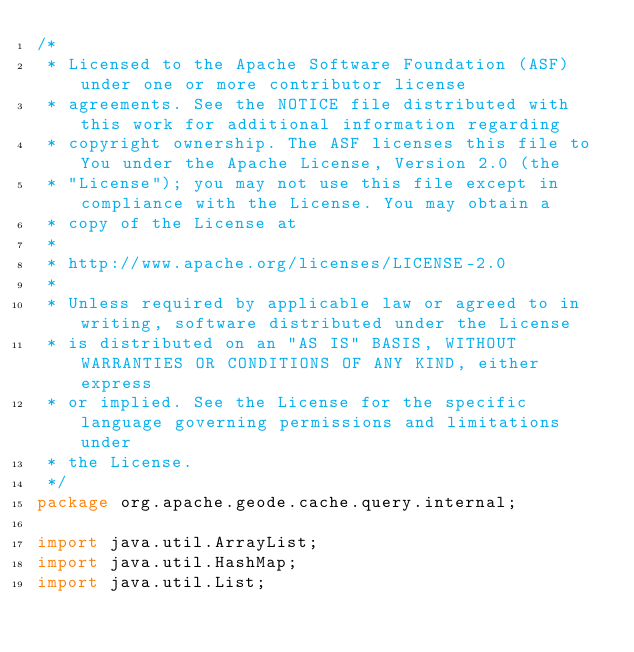<code> <loc_0><loc_0><loc_500><loc_500><_Java_>/*
 * Licensed to the Apache Software Foundation (ASF) under one or more contributor license
 * agreements. See the NOTICE file distributed with this work for additional information regarding
 * copyright ownership. The ASF licenses this file to You under the Apache License, Version 2.0 (the
 * "License"); you may not use this file except in compliance with the License. You may obtain a
 * copy of the License at
 *
 * http://www.apache.org/licenses/LICENSE-2.0
 *
 * Unless required by applicable law or agreed to in writing, software distributed under the License
 * is distributed on an "AS IS" BASIS, WITHOUT WARRANTIES OR CONDITIONS OF ANY KIND, either express
 * or implied. See the License for the specific language governing permissions and limitations under
 * the License.
 */
package org.apache.geode.cache.query.internal;

import java.util.ArrayList;
import java.util.HashMap;
import java.util.List;</code> 